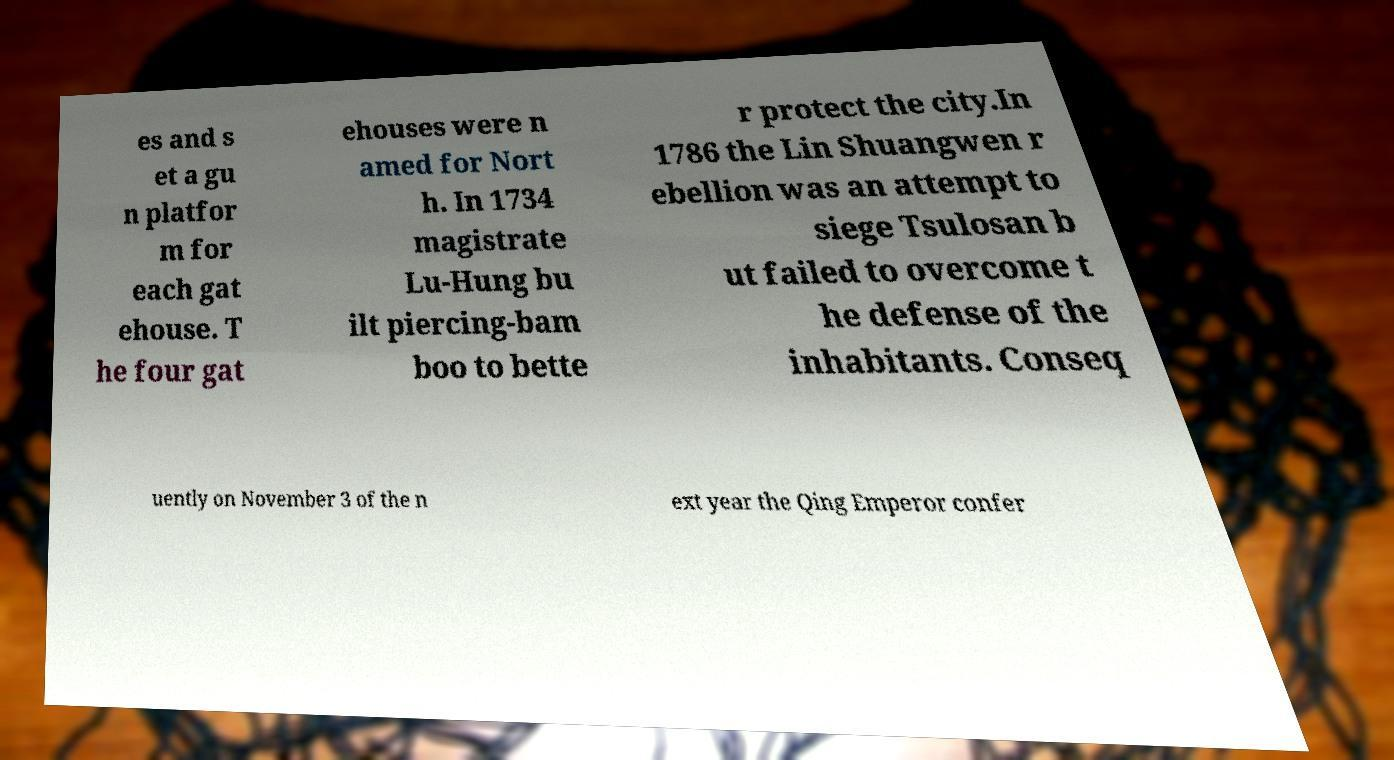I need the written content from this picture converted into text. Can you do that? es and s et a gu n platfor m for each gat ehouse. T he four gat ehouses were n amed for Nort h. In 1734 magistrate Lu-Hung bu ilt piercing-bam boo to bette r protect the city.In 1786 the Lin Shuangwen r ebellion was an attempt to siege Tsulosan b ut failed to overcome t he defense of the inhabitants. Conseq uently on November 3 of the n ext year the Qing Emperor confer 